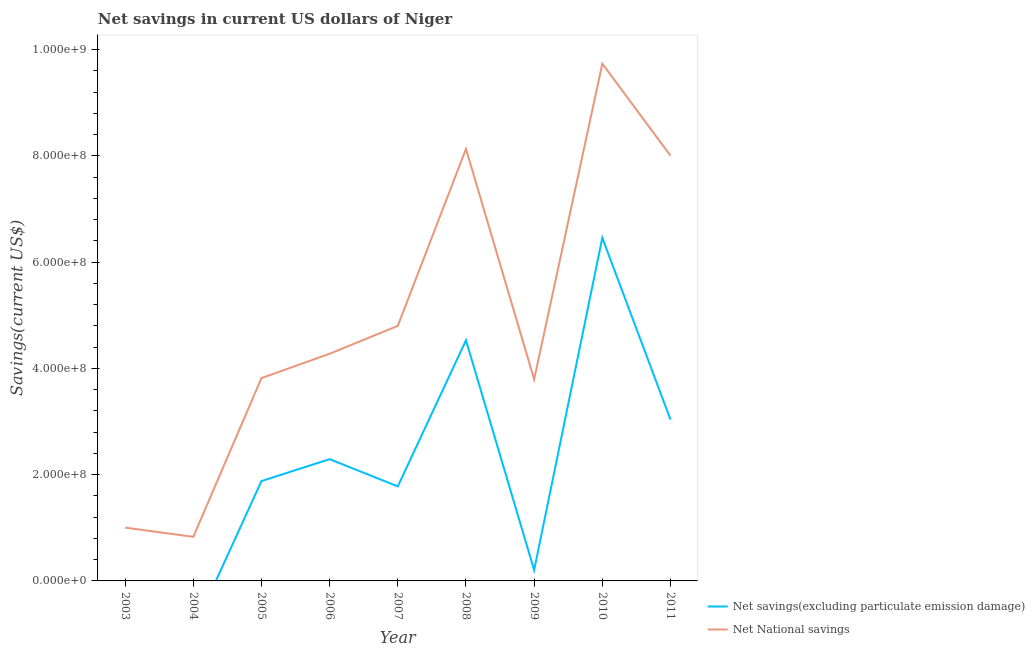How many different coloured lines are there?
Keep it short and to the point. 2. Does the line corresponding to net savings(excluding particulate emission damage) intersect with the line corresponding to net national savings?
Keep it short and to the point. No. Is the number of lines equal to the number of legend labels?
Provide a short and direct response. No. What is the net savings(excluding particulate emission damage) in 2010?
Offer a very short reply. 6.46e+08. Across all years, what is the maximum net savings(excluding particulate emission damage)?
Provide a short and direct response. 6.46e+08. What is the total net national savings in the graph?
Provide a short and direct response. 4.44e+09. What is the difference between the net national savings in 2005 and that in 2006?
Provide a short and direct response. -4.58e+07. What is the difference between the net savings(excluding particulate emission damage) in 2006 and the net national savings in 2004?
Ensure brevity in your answer.  1.46e+08. What is the average net national savings per year?
Provide a succinct answer. 4.93e+08. In the year 2011, what is the difference between the net national savings and net savings(excluding particulate emission damage)?
Offer a very short reply. 4.97e+08. In how many years, is the net national savings greater than 280000000 US$?
Provide a succinct answer. 7. What is the ratio of the net national savings in 2008 to that in 2009?
Provide a short and direct response. 2.14. Is the difference between the net savings(excluding particulate emission damage) in 2008 and 2009 greater than the difference between the net national savings in 2008 and 2009?
Give a very brief answer. No. What is the difference between the highest and the second highest net national savings?
Give a very brief answer. 1.60e+08. What is the difference between the highest and the lowest net savings(excluding particulate emission damage)?
Offer a very short reply. 6.46e+08. Does the net savings(excluding particulate emission damage) monotonically increase over the years?
Offer a terse response. No. Is the net national savings strictly less than the net savings(excluding particulate emission damage) over the years?
Give a very brief answer. No. How many lines are there?
Your answer should be compact. 2. How many years are there in the graph?
Your answer should be very brief. 9. Are the values on the major ticks of Y-axis written in scientific E-notation?
Offer a terse response. Yes. Where does the legend appear in the graph?
Keep it short and to the point. Bottom right. What is the title of the graph?
Offer a terse response. Net savings in current US dollars of Niger. Does "Import" appear as one of the legend labels in the graph?
Your answer should be compact. No. What is the label or title of the Y-axis?
Offer a very short reply. Savings(current US$). What is the Savings(current US$) of Net savings(excluding particulate emission damage) in 2003?
Offer a very short reply. 0. What is the Savings(current US$) in Net National savings in 2003?
Your answer should be very brief. 1.00e+08. What is the Savings(current US$) of Net National savings in 2004?
Provide a short and direct response. 8.30e+07. What is the Savings(current US$) of Net savings(excluding particulate emission damage) in 2005?
Ensure brevity in your answer.  1.88e+08. What is the Savings(current US$) in Net National savings in 2005?
Ensure brevity in your answer.  3.82e+08. What is the Savings(current US$) in Net savings(excluding particulate emission damage) in 2006?
Offer a terse response. 2.29e+08. What is the Savings(current US$) in Net National savings in 2006?
Provide a succinct answer. 4.28e+08. What is the Savings(current US$) in Net savings(excluding particulate emission damage) in 2007?
Your answer should be compact. 1.78e+08. What is the Savings(current US$) of Net National savings in 2007?
Provide a succinct answer. 4.80e+08. What is the Savings(current US$) in Net savings(excluding particulate emission damage) in 2008?
Offer a terse response. 4.53e+08. What is the Savings(current US$) of Net National savings in 2008?
Offer a very short reply. 8.13e+08. What is the Savings(current US$) of Net savings(excluding particulate emission damage) in 2009?
Your answer should be compact. 2.04e+07. What is the Savings(current US$) of Net National savings in 2009?
Keep it short and to the point. 3.79e+08. What is the Savings(current US$) in Net savings(excluding particulate emission damage) in 2010?
Offer a very short reply. 6.46e+08. What is the Savings(current US$) in Net National savings in 2010?
Keep it short and to the point. 9.73e+08. What is the Savings(current US$) in Net savings(excluding particulate emission damage) in 2011?
Give a very brief answer. 3.04e+08. What is the Savings(current US$) of Net National savings in 2011?
Offer a very short reply. 8.00e+08. Across all years, what is the maximum Savings(current US$) of Net savings(excluding particulate emission damage)?
Your answer should be very brief. 6.46e+08. Across all years, what is the maximum Savings(current US$) in Net National savings?
Make the answer very short. 9.73e+08. Across all years, what is the minimum Savings(current US$) of Net National savings?
Make the answer very short. 8.30e+07. What is the total Savings(current US$) of Net savings(excluding particulate emission damage) in the graph?
Make the answer very short. 2.02e+09. What is the total Savings(current US$) of Net National savings in the graph?
Your response must be concise. 4.44e+09. What is the difference between the Savings(current US$) in Net National savings in 2003 and that in 2004?
Provide a succinct answer. 1.74e+07. What is the difference between the Savings(current US$) of Net National savings in 2003 and that in 2005?
Make the answer very short. -2.81e+08. What is the difference between the Savings(current US$) in Net National savings in 2003 and that in 2006?
Offer a terse response. -3.27e+08. What is the difference between the Savings(current US$) of Net National savings in 2003 and that in 2007?
Provide a succinct answer. -3.80e+08. What is the difference between the Savings(current US$) of Net National savings in 2003 and that in 2008?
Provide a succinct answer. -7.13e+08. What is the difference between the Savings(current US$) in Net National savings in 2003 and that in 2009?
Your answer should be compact. -2.79e+08. What is the difference between the Savings(current US$) in Net National savings in 2003 and that in 2010?
Your response must be concise. -8.73e+08. What is the difference between the Savings(current US$) in Net National savings in 2003 and that in 2011?
Ensure brevity in your answer.  -7.00e+08. What is the difference between the Savings(current US$) of Net National savings in 2004 and that in 2005?
Ensure brevity in your answer.  -2.99e+08. What is the difference between the Savings(current US$) in Net National savings in 2004 and that in 2006?
Your response must be concise. -3.45e+08. What is the difference between the Savings(current US$) of Net National savings in 2004 and that in 2007?
Provide a succinct answer. -3.97e+08. What is the difference between the Savings(current US$) of Net National savings in 2004 and that in 2008?
Offer a terse response. -7.30e+08. What is the difference between the Savings(current US$) of Net National savings in 2004 and that in 2009?
Keep it short and to the point. -2.96e+08. What is the difference between the Savings(current US$) of Net National savings in 2004 and that in 2010?
Keep it short and to the point. -8.90e+08. What is the difference between the Savings(current US$) of Net National savings in 2004 and that in 2011?
Provide a short and direct response. -7.17e+08. What is the difference between the Savings(current US$) of Net savings(excluding particulate emission damage) in 2005 and that in 2006?
Provide a short and direct response. -4.12e+07. What is the difference between the Savings(current US$) in Net National savings in 2005 and that in 2006?
Provide a succinct answer. -4.58e+07. What is the difference between the Savings(current US$) in Net savings(excluding particulate emission damage) in 2005 and that in 2007?
Offer a terse response. 1.00e+07. What is the difference between the Savings(current US$) in Net National savings in 2005 and that in 2007?
Give a very brief answer. -9.83e+07. What is the difference between the Savings(current US$) of Net savings(excluding particulate emission damage) in 2005 and that in 2008?
Ensure brevity in your answer.  -2.65e+08. What is the difference between the Savings(current US$) of Net National savings in 2005 and that in 2008?
Offer a terse response. -4.31e+08. What is the difference between the Savings(current US$) of Net savings(excluding particulate emission damage) in 2005 and that in 2009?
Your answer should be compact. 1.68e+08. What is the difference between the Savings(current US$) of Net National savings in 2005 and that in 2009?
Give a very brief answer. 2.43e+06. What is the difference between the Savings(current US$) in Net savings(excluding particulate emission damage) in 2005 and that in 2010?
Give a very brief answer. -4.58e+08. What is the difference between the Savings(current US$) in Net National savings in 2005 and that in 2010?
Offer a very short reply. -5.92e+08. What is the difference between the Savings(current US$) in Net savings(excluding particulate emission damage) in 2005 and that in 2011?
Make the answer very short. -1.16e+08. What is the difference between the Savings(current US$) of Net National savings in 2005 and that in 2011?
Provide a short and direct response. -4.19e+08. What is the difference between the Savings(current US$) of Net savings(excluding particulate emission damage) in 2006 and that in 2007?
Your response must be concise. 5.12e+07. What is the difference between the Savings(current US$) in Net National savings in 2006 and that in 2007?
Your response must be concise. -5.25e+07. What is the difference between the Savings(current US$) of Net savings(excluding particulate emission damage) in 2006 and that in 2008?
Offer a terse response. -2.24e+08. What is the difference between the Savings(current US$) in Net National savings in 2006 and that in 2008?
Provide a short and direct response. -3.86e+08. What is the difference between the Savings(current US$) of Net savings(excluding particulate emission damage) in 2006 and that in 2009?
Provide a succinct answer. 2.09e+08. What is the difference between the Savings(current US$) in Net National savings in 2006 and that in 2009?
Your answer should be compact. 4.82e+07. What is the difference between the Savings(current US$) of Net savings(excluding particulate emission damage) in 2006 and that in 2010?
Keep it short and to the point. -4.17e+08. What is the difference between the Savings(current US$) of Net National savings in 2006 and that in 2010?
Offer a terse response. -5.46e+08. What is the difference between the Savings(current US$) of Net savings(excluding particulate emission damage) in 2006 and that in 2011?
Keep it short and to the point. -7.45e+07. What is the difference between the Savings(current US$) of Net National savings in 2006 and that in 2011?
Make the answer very short. -3.73e+08. What is the difference between the Savings(current US$) in Net savings(excluding particulate emission damage) in 2007 and that in 2008?
Provide a short and direct response. -2.75e+08. What is the difference between the Savings(current US$) in Net National savings in 2007 and that in 2008?
Your answer should be compact. -3.33e+08. What is the difference between the Savings(current US$) in Net savings(excluding particulate emission damage) in 2007 and that in 2009?
Your response must be concise. 1.58e+08. What is the difference between the Savings(current US$) of Net National savings in 2007 and that in 2009?
Make the answer very short. 1.01e+08. What is the difference between the Savings(current US$) in Net savings(excluding particulate emission damage) in 2007 and that in 2010?
Provide a short and direct response. -4.68e+08. What is the difference between the Savings(current US$) in Net National savings in 2007 and that in 2010?
Offer a very short reply. -4.93e+08. What is the difference between the Savings(current US$) in Net savings(excluding particulate emission damage) in 2007 and that in 2011?
Give a very brief answer. -1.26e+08. What is the difference between the Savings(current US$) in Net National savings in 2007 and that in 2011?
Offer a very short reply. -3.20e+08. What is the difference between the Savings(current US$) in Net savings(excluding particulate emission damage) in 2008 and that in 2009?
Make the answer very short. 4.33e+08. What is the difference between the Savings(current US$) of Net National savings in 2008 and that in 2009?
Give a very brief answer. 4.34e+08. What is the difference between the Savings(current US$) of Net savings(excluding particulate emission damage) in 2008 and that in 2010?
Your answer should be compact. -1.93e+08. What is the difference between the Savings(current US$) of Net National savings in 2008 and that in 2010?
Ensure brevity in your answer.  -1.60e+08. What is the difference between the Savings(current US$) in Net savings(excluding particulate emission damage) in 2008 and that in 2011?
Provide a succinct answer. 1.49e+08. What is the difference between the Savings(current US$) in Net National savings in 2008 and that in 2011?
Make the answer very short. 1.28e+07. What is the difference between the Savings(current US$) in Net savings(excluding particulate emission damage) in 2009 and that in 2010?
Offer a terse response. -6.25e+08. What is the difference between the Savings(current US$) of Net National savings in 2009 and that in 2010?
Offer a terse response. -5.94e+08. What is the difference between the Savings(current US$) in Net savings(excluding particulate emission damage) in 2009 and that in 2011?
Offer a terse response. -2.83e+08. What is the difference between the Savings(current US$) in Net National savings in 2009 and that in 2011?
Provide a short and direct response. -4.21e+08. What is the difference between the Savings(current US$) of Net savings(excluding particulate emission damage) in 2010 and that in 2011?
Provide a succinct answer. 3.42e+08. What is the difference between the Savings(current US$) of Net National savings in 2010 and that in 2011?
Give a very brief answer. 1.73e+08. What is the difference between the Savings(current US$) in Net savings(excluding particulate emission damage) in 2005 and the Savings(current US$) in Net National savings in 2006?
Offer a very short reply. -2.40e+08. What is the difference between the Savings(current US$) of Net savings(excluding particulate emission damage) in 2005 and the Savings(current US$) of Net National savings in 2007?
Your answer should be compact. -2.92e+08. What is the difference between the Savings(current US$) of Net savings(excluding particulate emission damage) in 2005 and the Savings(current US$) of Net National savings in 2008?
Offer a terse response. -6.25e+08. What is the difference between the Savings(current US$) of Net savings(excluding particulate emission damage) in 2005 and the Savings(current US$) of Net National savings in 2009?
Make the answer very short. -1.91e+08. What is the difference between the Savings(current US$) of Net savings(excluding particulate emission damage) in 2005 and the Savings(current US$) of Net National savings in 2010?
Make the answer very short. -7.85e+08. What is the difference between the Savings(current US$) of Net savings(excluding particulate emission damage) in 2005 and the Savings(current US$) of Net National savings in 2011?
Make the answer very short. -6.12e+08. What is the difference between the Savings(current US$) in Net savings(excluding particulate emission damage) in 2006 and the Savings(current US$) in Net National savings in 2007?
Make the answer very short. -2.51e+08. What is the difference between the Savings(current US$) of Net savings(excluding particulate emission damage) in 2006 and the Savings(current US$) of Net National savings in 2008?
Provide a short and direct response. -5.84e+08. What is the difference between the Savings(current US$) in Net savings(excluding particulate emission damage) in 2006 and the Savings(current US$) in Net National savings in 2009?
Your answer should be very brief. -1.50e+08. What is the difference between the Savings(current US$) of Net savings(excluding particulate emission damage) in 2006 and the Savings(current US$) of Net National savings in 2010?
Provide a short and direct response. -7.44e+08. What is the difference between the Savings(current US$) of Net savings(excluding particulate emission damage) in 2006 and the Savings(current US$) of Net National savings in 2011?
Ensure brevity in your answer.  -5.71e+08. What is the difference between the Savings(current US$) of Net savings(excluding particulate emission damage) in 2007 and the Savings(current US$) of Net National savings in 2008?
Ensure brevity in your answer.  -6.35e+08. What is the difference between the Savings(current US$) in Net savings(excluding particulate emission damage) in 2007 and the Savings(current US$) in Net National savings in 2009?
Your answer should be very brief. -2.01e+08. What is the difference between the Savings(current US$) of Net savings(excluding particulate emission damage) in 2007 and the Savings(current US$) of Net National savings in 2010?
Keep it short and to the point. -7.95e+08. What is the difference between the Savings(current US$) of Net savings(excluding particulate emission damage) in 2007 and the Savings(current US$) of Net National savings in 2011?
Ensure brevity in your answer.  -6.22e+08. What is the difference between the Savings(current US$) of Net savings(excluding particulate emission damage) in 2008 and the Savings(current US$) of Net National savings in 2009?
Offer a terse response. 7.36e+07. What is the difference between the Savings(current US$) of Net savings(excluding particulate emission damage) in 2008 and the Savings(current US$) of Net National savings in 2010?
Provide a short and direct response. -5.21e+08. What is the difference between the Savings(current US$) in Net savings(excluding particulate emission damage) in 2008 and the Savings(current US$) in Net National savings in 2011?
Your answer should be compact. -3.47e+08. What is the difference between the Savings(current US$) in Net savings(excluding particulate emission damage) in 2009 and the Savings(current US$) in Net National savings in 2010?
Provide a succinct answer. -9.53e+08. What is the difference between the Savings(current US$) in Net savings(excluding particulate emission damage) in 2009 and the Savings(current US$) in Net National savings in 2011?
Give a very brief answer. -7.80e+08. What is the difference between the Savings(current US$) of Net savings(excluding particulate emission damage) in 2010 and the Savings(current US$) of Net National savings in 2011?
Ensure brevity in your answer.  -1.55e+08. What is the average Savings(current US$) in Net savings(excluding particulate emission damage) per year?
Your answer should be compact. 2.24e+08. What is the average Savings(current US$) of Net National savings per year?
Provide a succinct answer. 4.93e+08. In the year 2005, what is the difference between the Savings(current US$) of Net savings(excluding particulate emission damage) and Savings(current US$) of Net National savings?
Keep it short and to the point. -1.94e+08. In the year 2006, what is the difference between the Savings(current US$) of Net savings(excluding particulate emission damage) and Savings(current US$) of Net National savings?
Your answer should be compact. -1.98e+08. In the year 2007, what is the difference between the Savings(current US$) of Net savings(excluding particulate emission damage) and Savings(current US$) of Net National savings?
Your answer should be very brief. -3.02e+08. In the year 2008, what is the difference between the Savings(current US$) in Net savings(excluding particulate emission damage) and Savings(current US$) in Net National savings?
Your answer should be very brief. -3.60e+08. In the year 2009, what is the difference between the Savings(current US$) in Net savings(excluding particulate emission damage) and Savings(current US$) in Net National savings?
Give a very brief answer. -3.59e+08. In the year 2010, what is the difference between the Savings(current US$) in Net savings(excluding particulate emission damage) and Savings(current US$) in Net National savings?
Keep it short and to the point. -3.28e+08. In the year 2011, what is the difference between the Savings(current US$) in Net savings(excluding particulate emission damage) and Savings(current US$) in Net National savings?
Your response must be concise. -4.97e+08. What is the ratio of the Savings(current US$) in Net National savings in 2003 to that in 2004?
Give a very brief answer. 1.21. What is the ratio of the Savings(current US$) in Net National savings in 2003 to that in 2005?
Your answer should be very brief. 0.26. What is the ratio of the Savings(current US$) of Net National savings in 2003 to that in 2006?
Provide a succinct answer. 0.23. What is the ratio of the Savings(current US$) of Net National savings in 2003 to that in 2007?
Make the answer very short. 0.21. What is the ratio of the Savings(current US$) in Net National savings in 2003 to that in 2008?
Provide a succinct answer. 0.12. What is the ratio of the Savings(current US$) in Net National savings in 2003 to that in 2009?
Keep it short and to the point. 0.26. What is the ratio of the Savings(current US$) of Net National savings in 2003 to that in 2010?
Your answer should be very brief. 0.1. What is the ratio of the Savings(current US$) in Net National savings in 2003 to that in 2011?
Your answer should be compact. 0.13. What is the ratio of the Savings(current US$) of Net National savings in 2004 to that in 2005?
Your answer should be compact. 0.22. What is the ratio of the Savings(current US$) in Net National savings in 2004 to that in 2006?
Provide a short and direct response. 0.19. What is the ratio of the Savings(current US$) in Net National savings in 2004 to that in 2007?
Keep it short and to the point. 0.17. What is the ratio of the Savings(current US$) of Net National savings in 2004 to that in 2008?
Your answer should be compact. 0.1. What is the ratio of the Savings(current US$) in Net National savings in 2004 to that in 2009?
Offer a terse response. 0.22. What is the ratio of the Savings(current US$) in Net National savings in 2004 to that in 2010?
Keep it short and to the point. 0.09. What is the ratio of the Savings(current US$) in Net National savings in 2004 to that in 2011?
Your answer should be very brief. 0.1. What is the ratio of the Savings(current US$) of Net savings(excluding particulate emission damage) in 2005 to that in 2006?
Keep it short and to the point. 0.82. What is the ratio of the Savings(current US$) in Net National savings in 2005 to that in 2006?
Offer a very short reply. 0.89. What is the ratio of the Savings(current US$) in Net savings(excluding particulate emission damage) in 2005 to that in 2007?
Your response must be concise. 1.06. What is the ratio of the Savings(current US$) in Net National savings in 2005 to that in 2007?
Provide a short and direct response. 0.8. What is the ratio of the Savings(current US$) in Net savings(excluding particulate emission damage) in 2005 to that in 2008?
Your response must be concise. 0.41. What is the ratio of the Savings(current US$) in Net National savings in 2005 to that in 2008?
Your answer should be very brief. 0.47. What is the ratio of the Savings(current US$) of Net savings(excluding particulate emission damage) in 2005 to that in 2009?
Offer a terse response. 9.22. What is the ratio of the Savings(current US$) of Net National savings in 2005 to that in 2009?
Offer a very short reply. 1.01. What is the ratio of the Savings(current US$) of Net savings(excluding particulate emission damage) in 2005 to that in 2010?
Provide a short and direct response. 0.29. What is the ratio of the Savings(current US$) of Net National savings in 2005 to that in 2010?
Provide a succinct answer. 0.39. What is the ratio of the Savings(current US$) in Net savings(excluding particulate emission damage) in 2005 to that in 2011?
Your response must be concise. 0.62. What is the ratio of the Savings(current US$) in Net National savings in 2005 to that in 2011?
Your answer should be very brief. 0.48. What is the ratio of the Savings(current US$) in Net savings(excluding particulate emission damage) in 2006 to that in 2007?
Provide a succinct answer. 1.29. What is the ratio of the Savings(current US$) in Net National savings in 2006 to that in 2007?
Provide a short and direct response. 0.89. What is the ratio of the Savings(current US$) in Net savings(excluding particulate emission damage) in 2006 to that in 2008?
Provide a succinct answer. 0.51. What is the ratio of the Savings(current US$) of Net National savings in 2006 to that in 2008?
Your answer should be compact. 0.53. What is the ratio of the Savings(current US$) of Net savings(excluding particulate emission damage) in 2006 to that in 2009?
Keep it short and to the point. 11.24. What is the ratio of the Savings(current US$) of Net National savings in 2006 to that in 2009?
Keep it short and to the point. 1.13. What is the ratio of the Savings(current US$) in Net savings(excluding particulate emission damage) in 2006 to that in 2010?
Your response must be concise. 0.35. What is the ratio of the Savings(current US$) in Net National savings in 2006 to that in 2010?
Give a very brief answer. 0.44. What is the ratio of the Savings(current US$) of Net savings(excluding particulate emission damage) in 2006 to that in 2011?
Provide a succinct answer. 0.75. What is the ratio of the Savings(current US$) in Net National savings in 2006 to that in 2011?
Make the answer very short. 0.53. What is the ratio of the Savings(current US$) of Net savings(excluding particulate emission damage) in 2007 to that in 2008?
Keep it short and to the point. 0.39. What is the ratio of the Savings(current US$) of Net National savings in 2007 to that in 2008?
Give a very brief answer. 0.59. What is the ratio of the Savings(current US$) of Net savings(excluding particulate emission damage) in 2007 to that in 2009?
Your answer should be compact. 8.73. What is the ratio of the Savings(current US$) of Net National savings in 2007 to that in 2009?
Keep it short and to the point. 1.27. What is the ratio of the Savings(current US$) in Net savings(excluding particulate emission damage) in 2007 to that in 2010?
Make the answer very short. 0.28. What is the ratio of the Savings(current US$) of Net National savings in 2007 to that in 2010?
Your response must be concise. 0.49. What is the ratio of the Savings(current US$) of Net savings(excluding particulate emission damage) in 2007 to that in 2011?
Your response must be concise. 0.59. What is the ratio of the Savings(current US$) of Net National savings in 2007 to that in 2011?
Provide a short and direct response. 0.6. What is the ratio of the Savings(current US$) of Net savings(excluding particulate emission damage) in 2008 to that in 2009?
Make the answer very short. 22.21. What is the ratio of the Savings(current US$) in Net National savings in 2008 to that in 2009?
Your response must be concise. 2.14. What is the ratio of the Savings(current US$) in Net savings(excluding particulate emission damage) in 2008 to that in 2010?
Your response must be concise. 0.7. What is the ratio of the Savings(current US$) in Net National savings in 2008 to that in 2010?
Keep it short and to the point. 0.84. What is the ratio of the Savings(current US$) in Net savings(excluding particulate emission damage) in 2008 to that in 2011?
Offer a very short reply. 1.49. What is the ratio of the Savings(current US$) in Net National savings in 2008 to that in 2011?
Give a very brief answer. 1.02. What is the ratio of the Savings(current US$) in Net savings(excluding particulate emission damage) in 2009 to that in 2010?
Your response must be concise. 0.03. What is the ratio of the Savings(current US$) in Net National savings in 2009 to that in 2010?
Provide a short and direct response. 0.39. What is the ratio of the Savings(current US$) in Net savings(excluding particulate emission damage) in 2009 to that in 2011?
Ensure brevity in your answer.  0.07. What is the ratio of the Savings(current US$) in Net National savings in 2009 to that in 2011?
Keep it short and to the point. 0.47. What is the ratio of the Savings(current US$) of Net savings(excluding particulate emission damage) in 2010 to that in 2011?
Make the answer very short. 2.13. What is the ratio of the Savings(current US$) of Net National savings in 2010 to that in 2011?
Provide a succinct answer. 1.22. What is the difference between the highest and the second highest Savings(current US$) in Net savings(excluding particulate emission damage)?
Make the answer very short. 1.93e+08. What is the difference between the highest and the second highest Savings(current US$) in Net National savings?
Offer a terse response. 1.60e+08. What is the difference between the highest and the lowest Savings(current US$) of Net savings(excluding particulate emission damage)?
Ensure brevity in your answer.  6.46e+08. What is the difference between the highest and the lowest Savings(current US$) of Net National savings?
Provide a short and direct response. 8.90e+08. 